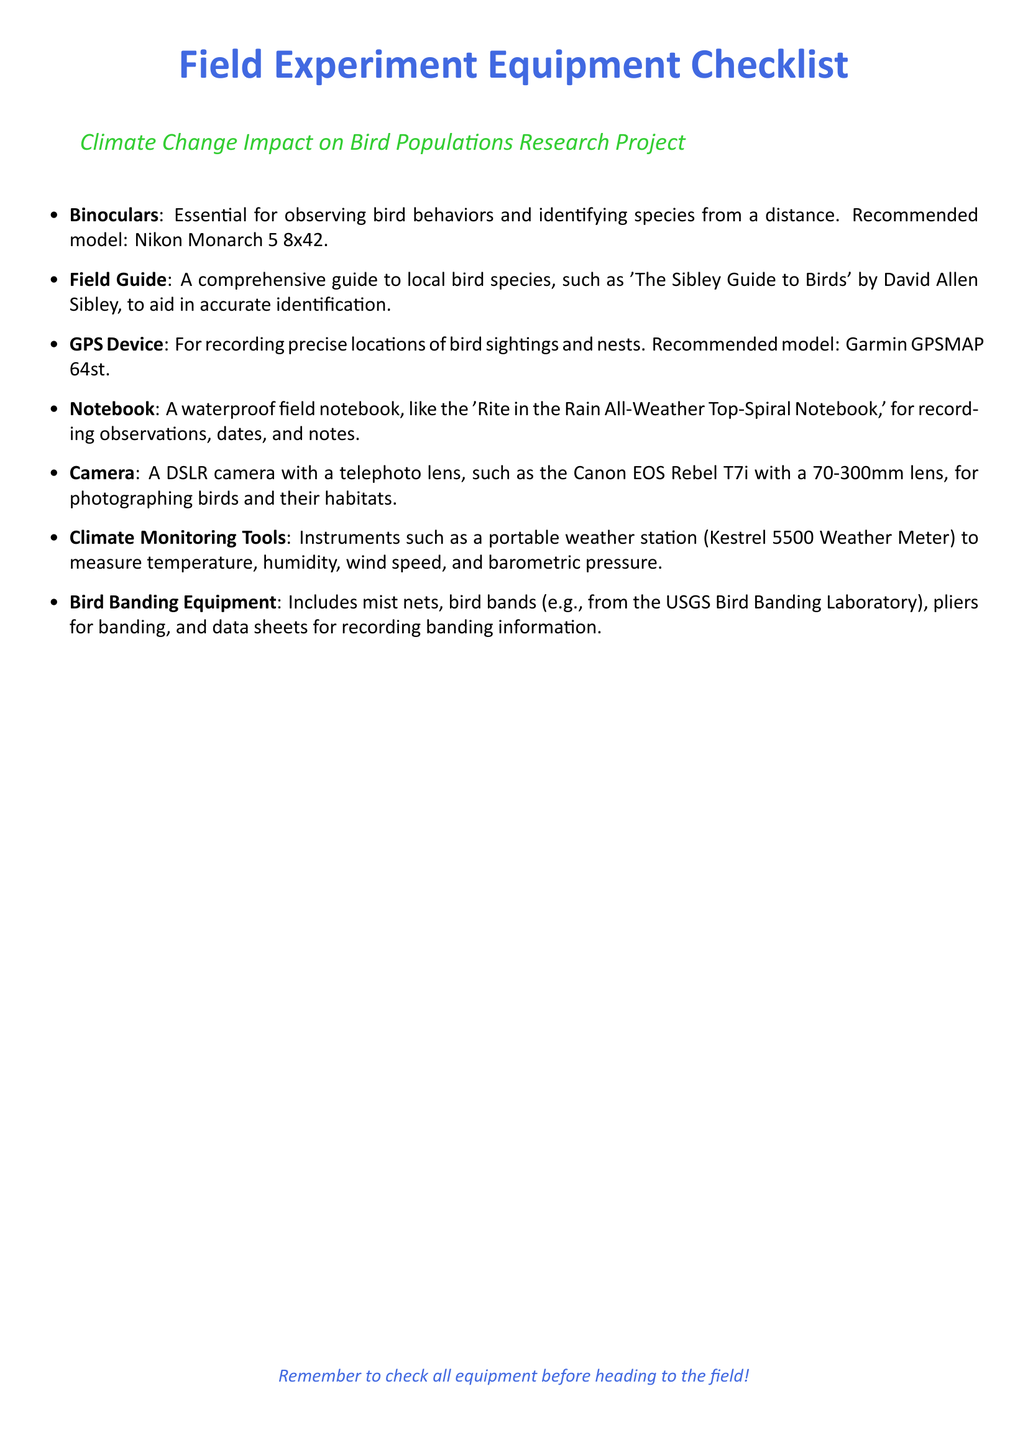what is the recommended model for binoculars? The document lists a specific model as a recommendation for binoculars, which is Nikon Monarch 5 8x42.
Answer: Nikon Monarch 5 8x42 which field guide is mentioned in the checklist? The document states a specific field guide that aids in accurate identification of local bird species, which is 'The Sibley Guide to Birds' by David Allen Sibley.
Answer: 'The Sibley Guide to Birds' what GPS device model is recommended? The document mentions a particular model recommended for GPS device use, which is Garmin GPSMAP 64st.
Answer: Garmin GPSMAP 64st what type of camera is suggested for the project? The document recommends a specific type of camera with a telephoto lens for photographing birds, which is Canon EOS Rebel T7i with a 70-300mm lens.
Answer: Canon EOS Rebel T7i with a 70-300mm lens what equipment is included in bird banding tools? The document lists several items that constitute bird banding equipment, including mist nets, bird bands, pliers for banding, and data sheets.
Answer: mist nets, bird bands, pliers, data sheets how many items are listed in the equipment checklist? The document features a total of seven items outlined in the equipment checklist for the field experiment.
Answer: seven what is the purpose of climate monitoring tools in this checklist? The document describes the role of climate monitoring tools as instruments for measuring weather-related variables crucial for the study.
Answer: measuring weather-related variables what is the key reminder mentioned at the end of the document? The document concludes with a reminder to check all equipment before heading to the field.
Answer: check all equipment 